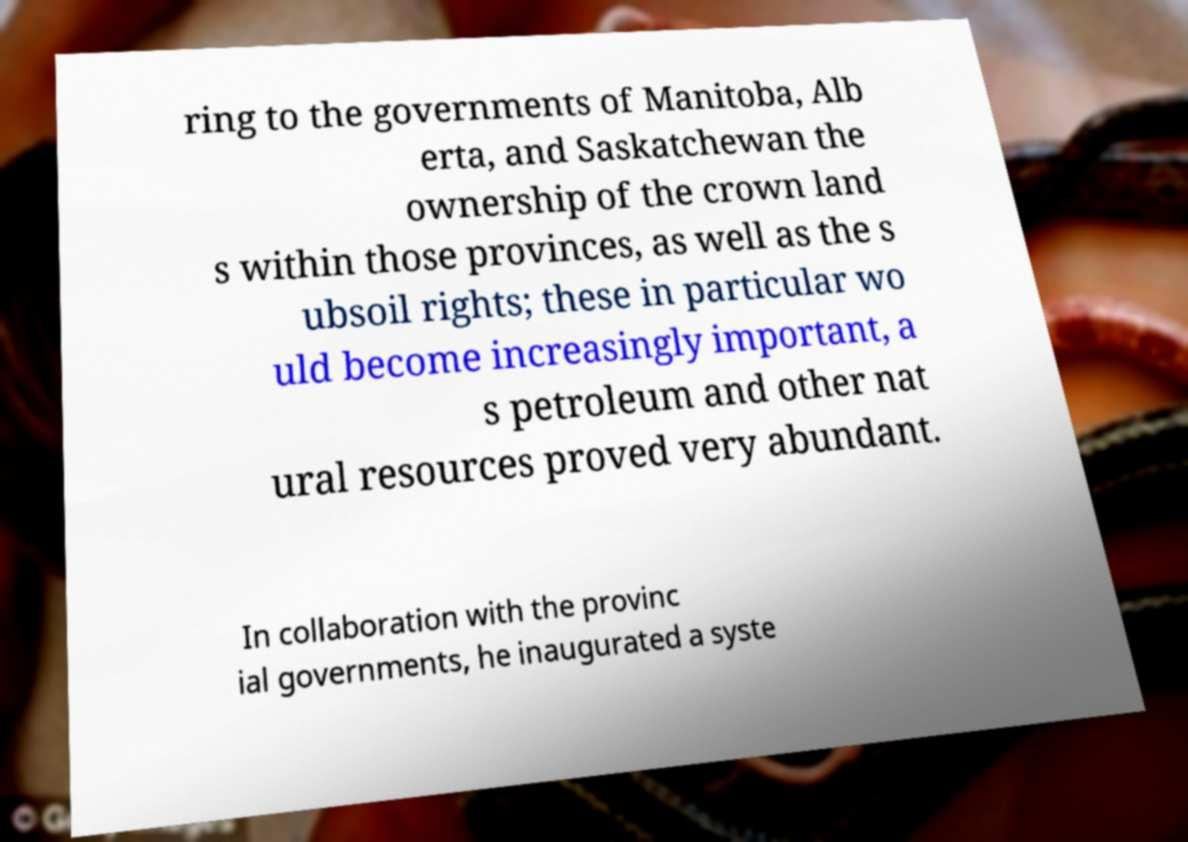Please identify and transcribe the text found in this image. ring to the governments of Manitoba, Alb erta, and Saskatchewan the ownership of the crown land s within those provinces, as well as the s ubsoil rights; these in particular wo uld become increasingly important, a s petroleum and other nat ural resources proved very abundant. In collaboration with the provinc ial governments, he inaugurated a syste 